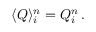<formula> <loc_0><loc_0><loc_500><loc_500>\langle Q \rangle _ { i } ^ { n } = Q _ { i } ^ { n } \, .</formula> 